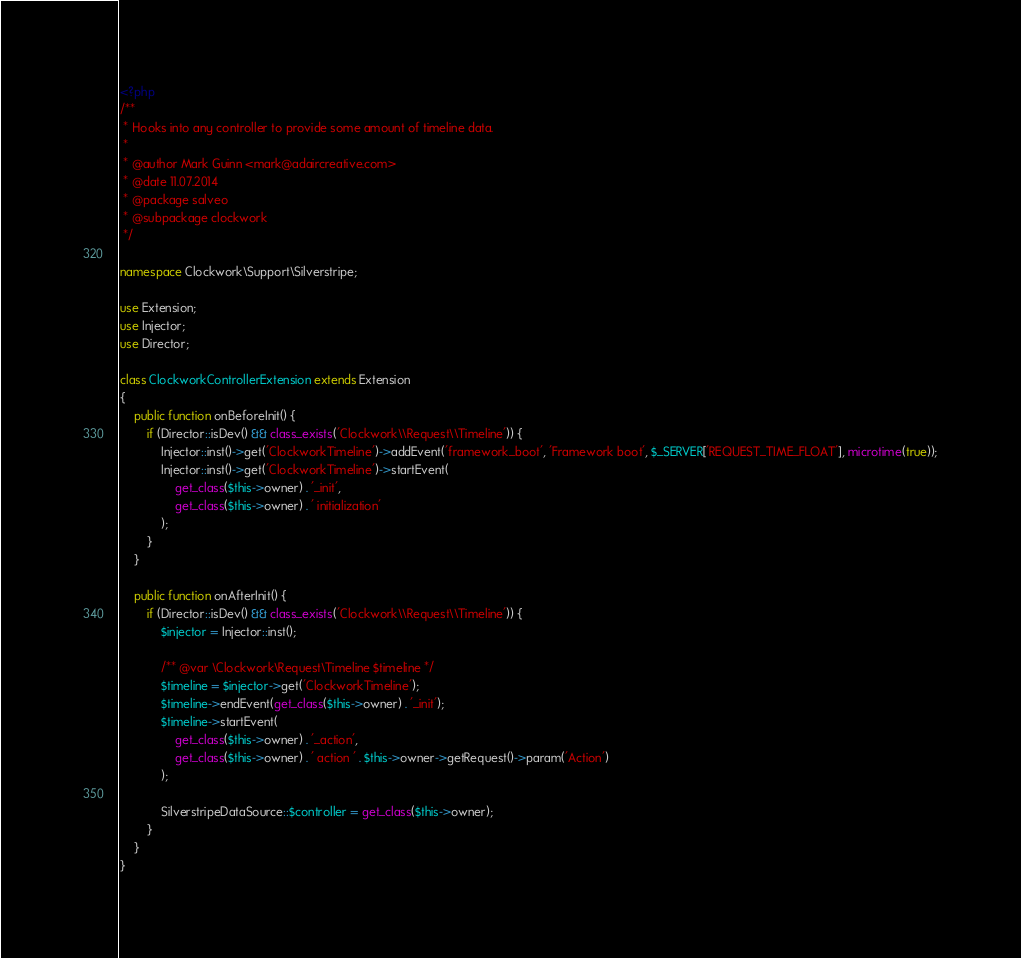Convert code to text. <code><loc_0><loc_0><loc_500><loc_500><_PHP_><?php
/**
 * Hooks into any controller to provide some amount of timeline data.
 *
 * @author Mark Guinn <mark@adaircreative.com>
 * @date 11.07.2014
 * @package salveo
 * @subpackage clockwork
 */

namespace Clockwork\Support\Silverstripe;

use Extension;
use Injector;
use Director;

class ClockworkControllerExtension extends Extension
{
    public function onBeforeInit() {
        if (Director::isDev() && class_exists('Clockwork\\Request\\Timeline')) {
			Injector::inst()->get('ClockworkTimeline')->addEvent('framework_boot', 'Framework boot', $_SERVER['REQUEST_TIME_FLOAT'], microtime(true));
            Injector::inst()->get('ClockworkTimeline')->startEvent(
                get_class($this->owner) . '_init',
                get_class($this->owner) . ' initialization'
            );
        }
    }

    public function onAfterInit() {
        if (Director::isDev() && class_exists('Clockwork\\Request\\Timeline')) {
            $injector = Injector::inst();

			/** @var \Clockwork\Request\Timeline $timeline */
			$timeline = $injector->get('ClockworkTimeline');
			$timeline->endEvent(get_class($this->owner) . '_init');
            $timeline->startEvent(
                get_class($this->owner) . '_action',
                get_class($this->owner) . ' action ' . $this->owner->getRequest()->param('Action')
            );

			SilverstripeDataSource::$controller = get_class($this->owner);
        }
    }
}
</code> 